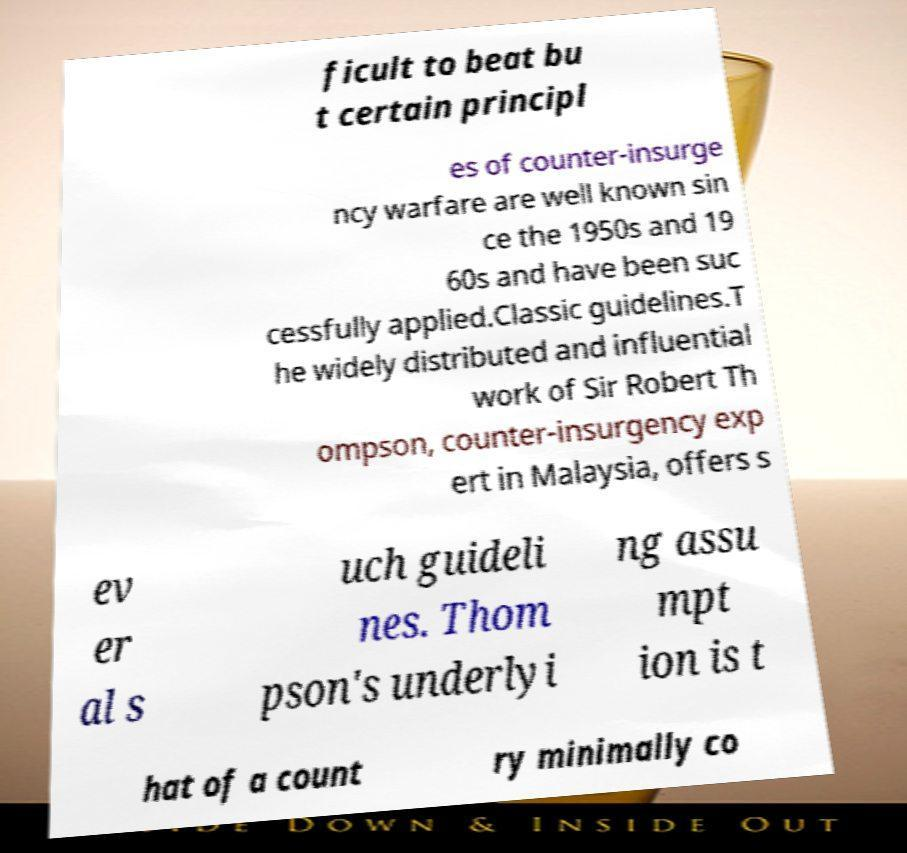Can you accurately transcribe the text from the provided image for me? ficult to beat bu t certain principl es of counter-insurge ncy warfare are well known sin ce the 1950s and 19 60s and have been suc cessfully applied.Classic guidelines.T he widely distributed and influential work of Sir Robert Th ompson, counter-insurgency exp ert in Malaysia, offers s ev er al s uch guideli nes. Thom pson's underlyi ng assu mpt ion is t hat of a count ry minimally co 